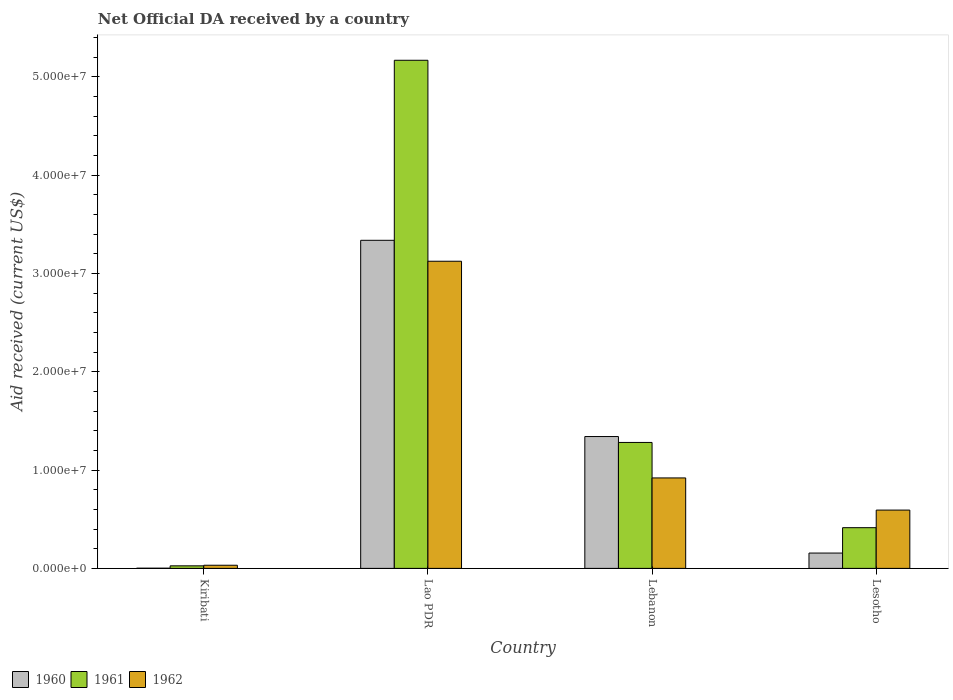How many different coloured bars are there?
Provide a succinct answer. 3. How many bars are there on the 3rd tick from the right?
Your answer should be very brief. 3. What is the label of the 2nd group of bars from the left?
Offer a very short reply. Lao PDR. What is the net official development assistance aid received in 1962 in Lebanon?
Your answer should be compact. 9.20e+06. Across all countries, what is the maximum net official development assistance aid received in 1961?
Keep it short and to the point. 5.17e+07. In which country was the net official development assistance aid received in 1962 maximum?
Give a very brief answer. Lao PDR. In which country was the net official development assistance aid received in 1961 minimum?
Your answer should be compact. Kiribati. What is the total net official development assistance aid received in 1961 in the graph?
Your answer should be compact. 6.89e+07. What is the difference between the net official development assistance aid received in 1960 in Kiribati and that in Lebanon?
Provide a succinct answer. -1.34e+07. What is the difference between the net official development assistance aid received in 1960 in Lao PDR and the net official development assistance aid received in 1962 in Kiribati?
Provide a succinct answer. 3.30e+07. What is the average net official development assistance aid received in 1962 per country?
Provide a succinct answer. 1.17e+07. What is the difference between the net official development assistance aid received of/in 1962 and net official development assistance aid received of/in 1960 in Lebanon?
Offer a terse response. -4.21e+06. What is the ratio of the net official development assistance aid received in 1962 in Lao PDR to that in Lebanon?
Provide a succinct answer. 3.4. Is the net official development assistance aid received in 1962 in Kiribati less than that in Lesotho?
Keep it short and to the point. Yes. Is the difference between the net official development assistance aid received in 1962 in Lebanon and Lesotho greater than the difference between the net official development assistance aid received in 1960 in Lebanon and Lesotho?
Offer a very short reply. No. What is the difference between the highest and the second highest net official development assistance aid received in 1961?
Keep it short and to the point. 3.89e+07. What is the difference between the highest and the lowest net official development assistance aid received in 1961?
Offer a terse response. 5.14e+07. In how many countries, is the net official development assistance aid received in 1960 greater than the average net official development assistance aid received in 1960 taken over all countries?
Give a very brief answer. 2. Is the sum of the net official development assistance aid received in 1961 in Kiribati and Lao PDR greater than the maximum net official development assistance aid received in 1960 across all countries?
Ensure brevity in your answer.  Yes. Are all the bars in the graph horizontal?
Make the answer very short. No. What is the difference between two consecutive major ticks on the Y-axis?
Make the answer very short. 1.00e+07. Are the values on the major ticks of Y-axis written in scientific E-notation?
Your answer should be compact. Yes. Does the graph contain any zero values?
Ensure brevity in your answer.  No. Does the graph contain grids?
Provide a succinct answer. No. What is the title of the graph?
Provide a short and direct response. Net Official DA received by a country. Does "1993" appear as one of the legend labels in the graph?
Your response must be concise. No. What is the label or title of the Y-axis?
Ensure brevity in your answer.  Aid received (current US$). What is the Aid received (current US$) of 1960 in Kiribati?
Provide a short and direct response. 2.00e+04. What is the Aid received (current US$) of 1961 in Kiribati?
Provide a succinct answer. 2.60e+05. What is the Aid received (current US$) of 1962 in Kiribati?
Provide a succinct answer. 3.20e+05. What is the Aid received (current US$) in 1960 in Lao PDR?
Offer a very short reply. 3.34e+07. What is the Aid received (current US$) of 1961 in Lao PDR?
Your response must be concise. 5.17e+07. What is the Aid received (current US$) in 1962 in Lao PDR?
Give a very brief answer. 3.12e+07. What is the Aid received (current US$) in 1960 in Lebanon?
Provide a succinct answer. 1.34e+07. What is the Aid received (current US$) of 1961 in Lebanon?
Make the answer very short. 1.28e+07. What is the Aid received (current US$) of 1962 in Lebanon?
Offer a very short reply. 9.20e+06. What is the Aid received (current US$) of 1960 in Lesotho?
Your answer should be compact. 1.56e+06. What is the Aid received (current US$) in 1961 in Lesotho?
Your answer should be compact. 4.14e+06. What is the Aid received (current US$) of 1962 in Lesotho?
Keep it short and to the point. 5.93e+06. Across all countries, what is the maximum Aid received (current US$) in 1960?
Offer a very short reply. 3.34e+07. Across all countries, what is the maximum Aid received (current US$) of 1961?
Give a very brief answer. 5.17e+07. Across all countries, what is the maximum Aid received (current US$) of 1962?
Your response must be concise. 3.12e+07. Across all countries, what is the minimum Aid received (current US$) in 1961?
Provide a succinct answer. 2.60e+05. Across all countries, what is the minimum Aid received (current US$) of 1962?
Your answer should be very brief. 3.20e+05. What is the total Aid received (current US$) in 1960 in the graph?
Ensure brevity in your answer.  4.84e+07. What is the total Aid received (current US$) in 1961 in the graph?
Provide a succinct answer. 6.89e+07. What is the total Aid received (current US$) of 1962 in the graph?
Keep it short and to the point. 4.67e+07. What is the difference between the Aid received (current US$) of 1960 in Kiribati and that in Lao PDR?
Your answer should be compact. -3.34e+07. What is the difference between the Aid received (current US$) in 1961 in Kiribati and that in Lao PDR?
Offer a very short reply. -5.14e+07. What is the difference between the Aid received (current US$) of 1962 in Kiribati and that in Lao PDR?
Keep it short and to the point. -3.09e+07. What is the difference between the Aid received (current US$) in 1960 in Kiribati and that in Lebanon?
Offer a very short reply. -1.34e+07. What is the difference between the Aid received (current US$) in 1961 in Kiribati and that in Lebanon?
Make the answer very short. -1.26e+07. What is the difference between the Aid received (current US$) in 1962 in Kiribati and that in Lebanon?
Your answer should be compact. -8.88e+06. What is the difference between the Aid received (current US$) of 1960 in Kiribati and that in Lesotho?
Your answer should be compact. -1.54e+06. What is the difference between the Aid received (current US$) in 1961 in Kiribati and that in Lesotho?
Offer a terse response. -3.88e+06. What is the difference between the Aid received (current US$) of 1962 in Kiribati and that in Lesotho?
Your answer should be very brief. -5.61e+06. What is the difference between the Aid received (current US$) in 1960 in Lao PDR and that in Lebanon?
Offer a very short reply. 2.00e+07. What is the difference between the Aid received (current US$) of 1961 in Lao PDR and that in Lebanon?
Keep it short and to the point. 3.89e+07. What is the difference between the Aid received (current US$) of 1962 in Lao PDR and that in Lebanon?
Give a very brief answer. 2.20e+07. What is the difference between the Aid received (current US$) in 1960 in Lao PDR and that in Lesotho?
Your response must be concise. 3.18e+07. What is the difference between the Aid received (current US$) of 1961 in Lao PDR and that in Lesotho?
Provide a short and direct response. 4.75e+07. What is the difference between the Aid received (current US$) of 1962 in Lao PDR and that in Lesotho?
Your response must be concise. 2.53e+07. What is the difference between the Aid received (current US$) of 1960 in Lebanon and that in Lesotho?
Provide a succinct answer. 1.18e+07. What is the difference between the Aid received (current US$) of 1961 in Lebanon and that in Lesotho?
Provide a succinct answer. 8.67e+06. What is the difference between the Aid received (current US$) of 1962 in Lebanon and that in Lesotho?
Provide a succinct answer. 3.27e+06. What is the difference between the Aid received (current US$) of 1960 in Kiribati and the Aid received (current US$) of 1961 in Lao PDR?
Give a very brief answer. -5.17e+07. What is the difference between the Aid received (current US$) in 1960 in Kiribati and the Aid received (current US$) in 1962 in Lao PDR?
Your response must be concise. -3.12e+07. What is the difference between the Aid received (current US$) of 1961 in Kiribati and the Aid received (current US$) of 1962 in Lao PDR?
Ensure brevity in your answer.  -3.10e+07. What is the difference between the Aid received (current US$) of 1960 in Kiribati and the Aid received (current US$) of 1961 in Lebanon?
Your answer should be compact. -1.28e+07. What is the difference between the Aid received (current US$) of 1960 in Kiribati and the Aid received (current US$) of 1962 in Lebanon?
Ensure brevity in your answer.  -9.18e+06. What is the difference between the Aid received (current US$) in 1961 in Kiribati and the Aid received (current US$) in 1962 in Lebanon?
Offer a very short reply. -8.94e+06. What is the difference between the Aid received (current US$) in 1960 in Kiribati and the Aid received (current US$) in 1961 in Lesotho?
Ensure brevity in your answer.  -4.12e+06. What is the difference between the Aid received (current US$) of 1960 in Kiribati and the Aid received (current US$) of 1962 in Lesotho?
Offer a terse response. -5.91e+06. What is the difference between the Aid received (current US$) of 1961 in Kiribati and the Aid received (current US$) of 1962 in Lesotho?
Your answer should be very brief. -5.67e+06. What is the difference between the Aid received (current US$) of 1960 in Lao PDR and the Aid received (current US$) of 1961 in Lebanon?
Offer a terse response. 2.06e+07. What is the difference between the Aid received (current US$) of 1960 in Lao PDR and the Aid received (current US$) of 1962 in Lebanon?
Provide a succinct answer. 2.42e+07. What is the difference between the Aid received (current US$) of 1961 in Lao PDR and the Aid received (current US$) of 1962 in Lebanon?
Your response must be concise. 4.25e+07. What is the difference between the Aid received (current US$) in 1960 in Lao PDR and the Aid received (current US$) in 1961 in Lesotho?
Keep it short and to the point. 2.92e+07. What is the difference between the Aid received (current US$) in 1960 in Lao PDR and the Aid received (current US$) in 1962 in Lesotho?
Offer a very short reply. 2.74e+07. What is the difference between the Aid received (current US$) of 1961 in Lao PDR and the Aid received (current US$) of 1962 in Lesotho?
Your answer should be very brief. 4.58e+07. What is the difference between the Aid received (current US$) in 1960 in Lebanon and the Aid received (current US$) in 1961 in Lesotho?
Keep it short and to the point. 9.27e+06. What is the difference between the Aid received (current US$) in 1960 in Lebanon and the Aid received (current US$) in 1962 in Lesotho?
Give a very brief answer. 7.48e+06. What is the difference between the Aid received (current US$) in 1961 in Lebanon and the Aid received (current US$) in 1962 in Lesotho?
Provide a succinct answer. 6.88e+06. What is the average Aid received (current US$) of 1960 per country?
Provide a short and direct response. 1.21e+07. What is the average Aid received (current US$) in 1961 per country?
Provide a short and direct response. 1.72e+07. What is the average Aid received (current US$) of 1962 per country?
Provide a short and direct response. 1.17e+07. What is the difference between the Aid received (current US$) of 1961 and Aid received (current US$) of 1962 in Kiribati?
Give a very brief answer. -6.00e+04. What is the difference between the Aid received (current US$) in 1960 and Aid received (current US$) in 1961 in Lao PDR?
Make the answer very short. -1.83e+07. What is the difference between the Aid received (current US$) of 1960 and Aid received (current US$) of 1962 in Lao PDR?
Give a very brief answer. 2.13e+06. What is the difference between the Aid received (current US$) in 1961 and Aid received (current US$) in 1962 in Lao PDR?
Ensure brevity in your answer.  2.04e+07. What is the difference between the Aid received (current US$) in 1960 and Aid received (current US$) in 1962 in Lebanon?
Offer a terse response. 4.21e+06. What is the difference between the Aid received (current US$) in 1961 and Aid received (current US$) in 1962 in Lebanon?
Give a very brief answer. 3.61e+06. What is the difference between the Aid received (current US$) in 1960 and Aid received (current US$) in 1961 in Lesotho?
Your answer should be very brief. -2.58e+06. What is the difference between the Aid received (current US$) in 1960 and Aid received (current US$) in 1962 in Lesotho?
Keep it short and to the point. -4.37e+06. What is the difference between the Aid received (current US$) of 1961 and Aid received (current US$) of 1962 in Lesotho?
Offer a terse response. -1.79e+06. What is the ratio of the Aid received (current US$) in 1960 in Kiribati to that in Lao PDR?
Provide a succinct answer. 0. What is the ratio of the Aid received (current US$) in 1961 in Kiribati to that in Lao PDR?
Offer a very short reply. 0.01. What is the ratio of the Aid received (current US$) of 1962 in Kiribati to that in Lao PDR?
Make the answer very short. 0.01. What is the ratio of the Aid received (current US$) of 1960 in Kiribati to that in Lebanon?
Provide a short and direct response. 0. What is the ratio of the Aid received (current US$) in 1961 in Kiribati to that in Lebanon?
Make the answer very short. 0.02. What is the ratio of the Aid received (current US$) of 1962 in Kiribati to that in Lebanon?
Your response must be concise. 0.03. What is the ratio of the Aid received (current US$) of 1960 in Kiribati to that in Lesotho?
Your answer should be very brief. 0.01. What is the ratio of the Aid received (current US$) of 1961 in Kiribati to that in Lesotho?
Ensure brevity in your answer.  0.06. What is the ratio of the Aid received (current US$) in 1962 in Kiribati to that in Lesotho?
Your response must be concise. 0.05. What is the ratio of the Aid received (current US$) of 1960 in Lao PDR to that in Lebanon?
Make the answer very short. 2.49. What is the ratio of the Aid received (current US$) of 1961 in Lao PDR to that in Lebanon?
Your answer should be compact. 4.03. What is the ratio of the Aid received (current US$) of 1962 in Lao PDR to that in Lebanon?
Your answer should be very brief. 3.4. What is the ratio of the Aid received (current US$) in 1960 in Lao PDR to that in Lesotho?
Provide a short and direct response. 21.39. What is the ratio of the Aid received (current US$) of 1961 in Lao PDR to that in Lesotho?
Provide a short and direct response. 12.48. What is the ratio of the Aid received (current US$) in 1962 in Lao PDR to that in Lesotho?
Your response must be concise. 5.27. What is the ratio of the Aid received (current US$) of 1960 in Lebanon to that in Lesotho?
Ensure brevity in your answer.  8.6. What is the ratio of the Aid received (current US$) of 1961 in Lebanon to that in Lesotho?
Your answer should be compact. 3.09. What is the ratio of the Aid received (current US$) of 1962 in Lebanon to that in Lesotho?
Your response must be concise. 1.55. What is the difference between the highest and the second highest Aid received (current US$) in 1960?
Ensure brevity in your answer.  2.00e+07. What is the difference between the highest and the second highest Aid received (current US$) in 1961?
Your answer should be compact. 3.89e+07. What is the difference between the highest and the second highest Aid received (current US$) of 1962?
Offer a terse response. 2.20e+07. What is the difference between the highest and the lowest Aid received (current US$) in 1960?
Provide a short and direct response. 3.34e+07. What is the difference between the highest and the lowest Aid received (current US$) of 1961?
Your response must be concise. 5.14e+07. What is the difference between the highest and the lowest Aid received (current US$) in 1962?
Your answer should be compact. 3.09e+07. 